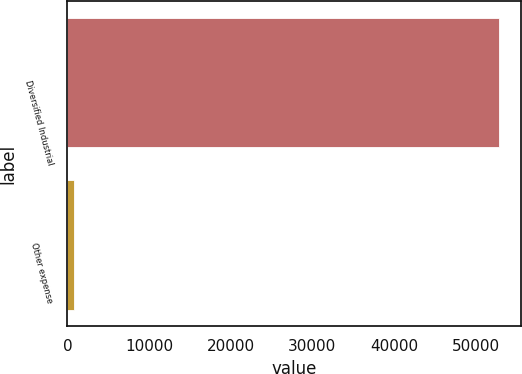Convert chart to OTSL. <chart><loc_0><loc_0><loc_500><loc_500><bar_chart><fcel>Diversified Industrial<fcel>Other expense<nl><fcel>52939<fcel>784<nl></chart> 